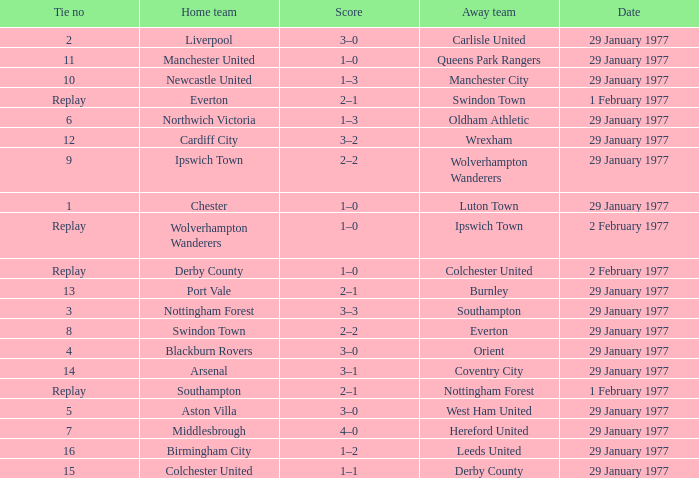Which away team has a tie number of 3? Southampton. 